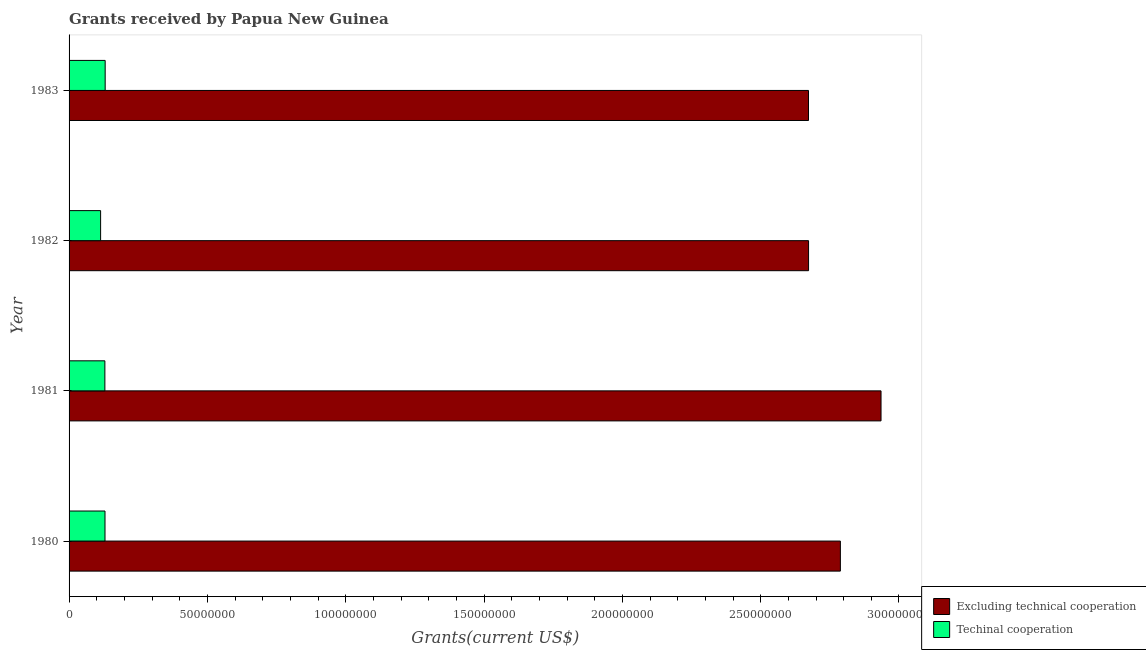How many different coloured bars are there?
Make the answer very short. 2. How many groups of bars are there?
Your response must be concise. 4. Are the number of bars per tick equal to the number of legend labels?
Make the answer very short. Yes. Are the number of bars on each tick of the Y-axis equal?
Your response must be concise. Yes. In how many cases, is the number of bars for a given year not equal to the number of legend labels?
Your answer should be very brief. 0. What is the amount of grants received(excluding technical cooperation) in 1981?
Your answer should be compact. 2.94e+08. Across all years, what is the maximum amount of grants received(including technical cooperation)?
Your response must be concise. 1.30e+07. Across all years, what is the minimum amount of grants received(including technical cooperation)?
Offer a terse response. 1.14e+07. In which year was the amount of grants received(including technical cooperation) minimum?
Your response must be concise. 1982. What is the total amount of grants received(excluding technical cooperation) in the graph?
Provide a short and direct response. 1.11e+09. What is the difference between the amount of grants received(excluding technical cooperation) in 1980 and that in 1981?
Offer a terse response. -1.47e+07. What is the difference between the amount of grants received(excluding technical cooperation) in 1980 and the amount of grants received(including technical cooperation) in 1983?
Offer a terse response. 2.66e+08. What is the average amount of grants received(including technical cooperation) per year?
Provide a succinct answer. 1.26e+07. In the year 1980, what is the difference between the amount of grants received(including technical cooperation) and amount of grants received(excluding technical cooperation)?
Provide a short and direct response. -2.66e+08. In how many years, is the amount of grants received(excluding technical cooperation) greater than 160000000 US$?
Offer a terse response. 4. What is the ratio of the amount of grants received(including technical cooperation) in 1982 to that in 1983?
Provide a succinct answer. 0.87. Is the difference between the amount of grants received(including technical cooperation) in 1980 and 1981 greater than the difference between the amount of grants received(excluding technical cooperation) in 1980 and 1981?
Offer a terse response. Yes. What is the difference between the highest and the second highest amount of grants received(excluding technical cooperation)?
Your answer should be compact. 1.47e+07. What is the difference between the highest and the lowest amount of grants received(including technical cooperation)?
Make the answer very short. 1.65e+06. In how many years, is the amount of grants received(including technical cooperation) greater than the average amount of grants received(including technical cooperation) taken over all years?
Your answer should be very brief. 3. What does the 2nd bar from the top in 1980 represents?
Provide a short and direct response. Excluding technical cooperation. What does the 2nd bar from the bottom in 1982 represents?
Make the answer very short. Techinal cooperation. How many bars are there?
Your answer should be compact. 8. Are all the bars in the graph horizontal?
Your response must be concise. Yes. Where does the legend appear in the graph?
Offer a terse response. Bottom right. How many legend labels are there?
Provide a short and direct response. 2. What is the title of the graph?
Keep it short and to the point. Grants received by Papua New Guinea. Does "current US$" appear as one of the legend labels in the graph?
Offer a very short reply. No. What is the label or title of the X-axis?
Provide a succinct answer. Grants(current US$). What is the Grants(current US$) in Excluding technical cooperation in 1980?
Your answer should be very brief. 2.79e+08. What is the Grants(current US$) in Techinal cooperation in 1980?
Offer a terse response. 1.30e+07. What is the Grants(current US$) of Excluding technical cooperation in 1981?
Your answer should be very brief. 2.94e+08. What is the Grants(current US$) of Techinal cooperation in 1981?
Your answer should be compact. 1.29e+07. What is the Grants(current US$) in Excluding technical cooperation in 1982?
Make the answer very short. 2.67e+08. What is the Grants(current US$) in Techinal cooperation in 1982?
Offer a terse response. 1.14e+07. What is the Grants(current US$) of Excluding technical cooperation in 1983?
Your response must be concise. 2.67e+08. What is the Grants(current US$) of Techinal cooperation in 1983?
Offer a terse response. 1.30e+07. Across all years, what is the maximum Grants(current US$) of Excluding technical cooperation?
Your answer should be compact. 2.94e+08. Across all years, what is the maximum Grants(current US$) in Techinal cooperation?
Keep it short and to the point. 1.30e+07. Across all years, what is the minimum Grants(current US$) in Excluding technical cooperation?
Your answer should be very brief. 2.67e+08. Across all years, what is the minimum Grants(current US$) of Techinal cooperation?
Offer a terse response. 1.14e+07. What is the total Grants(current US$) in Excluding technical cooperation in the graph?
Give a very brief answer. 1.11e+09. What is the total Grants(current US$) in Techinal cooperation in the graph?
Ensure brevity in your answer.  5.04e+07. What is the difference between the Grants(current US$) in Excluding technical cooperation in 1980 and that in 1981?
Make the answer very short. -1.47e+07. What is the difference between the Grants(current US$) in Excluding technical cooperation in 1980 and that in 1982?
Provide a short and direct response. 1.15e+07. What is the difference between the Grants(current US$) of Techinal cooperation in 1980 and that in 1982?
Your answer should be compact. 1.59e+06. What is the difference between the Grants(current US$) of Excluding technical cooperation in 1980 and that in 1983?
Offer a terse response. 1.15e+07. What is the difference between the Grants(current US$) in Excluding technical cooperation in 1981 and that in 1982?
Provide a succinct answer. 2.62e+07. What is the difference between the Grants(current US$) in Techinal cooperation in 1981 and that in 1982?
Make the answer very short. 1.54e+06. What is the difference between the Grants(current US$) of Excluding technical cooperation in 1981 and that in 1983?
Your response must be concise. 2.62e+07. What is the difference between the Grants(current US$) of Techinal cooperation in 1982 and that in 1983?
Give a very brief answer. -1.65e+06. What is the difference between the Grants(current US$) in Excluding technical cooperation in 1980 and the Grants(current US$) in Techinal cooperation in 1981?
Provide a short and direct response. 2.66e+08. What is the difference between the Grants(current US$) in Excluding technical cooperation in 1980 and the Grants(current US$) in Techinal cooperation in 1982?
Provide a succinct answer. 2.67e+08. What is the difference between the Grants(current US$) of Excluding technical cooperation in 1980 and the Grants(current US$) of Techinal cooperation in 1983?
Your answer should be very brief. 2.66e+08. What is the difference between the Grants(current US$) in Excluding technical cooperation in 1981 and the Grants(current US$) in Techinal cooperation in 1982?
Your answer should be very brief. 2.82e+08. What is the difference between the Grants(current US$) of Excluding technical cooperation in 1981 and the Grants(current US$) of Techinal cooperation in 1983?
Your answer should be very brief. 2.80e+08. What is the difference between the Grants(current US$) of Excluding technical cooperation in 1982 and the Grants(current US$) of Techinal cooperation in 1983?
Ensure brevity in your answer.  2.54e+08. What is the average Grants(current US$) of Excluding technical cooperation per year?
Your response must be concise. 2.77e+08. What is the average Grants(current US$) in Techinal cooperation per year?
Offer a very short reply. 1.26e+07. In the year 1980, what is the difference between the Grants(current US$) in Excluding technical cooperation and Grants(current US$) in Techinal cooperation?
Offer a terse response. 2.66e+08. In the year 1981, what is the difference between the Grants(current US$) in Excluding technical cooperation and Grants(current US$) in Techinal cooperation?
Provide a short and direct response. 2.81e+08. In the year 1982, what is the difference between the Grants(current US$) of Excluding technical cooperation and Grants(current US$) of Techinal cooperation?
Offer a terse response. 2.56e+08. In the year 1983, what is the difference between the Grants(current US$) in Excluding technical cooperation and Grants(current US$) in Techinal cooperation?
Make the answer very short. 2.54e+08. What is the ratio of the Grants(current US$) of Excluding technical cooperation in 1980 to that in 1981?
Give a very brief answer. 0.95. What is the ratio of the Grants(current US$) in Excluding technical cooperation in 1980 to that in 1982?
Your answer should be very brief. 1.04. What is the ratio of the Grants(current US$) in Techinal cooperation in 1980 to that in 1982?
Offer a terse response. 1.14. What is the ratio of the Grants(current US$) in Excluding technical cooperation in 1980 to that in 1983?
Ensure brevity in your answer.  1.04. What is the ratio of the Grants(current US$) of Techinal cooperation in 1980 to that in 1983?
Keep it short and to the point. 1. What is the ratio of the Grants(current US$) in Excluding technical cooperation in 1981 to that in 1982?
Your answer should be very brief. 1.1. What is the ratio of the Grants(current US$) in Techinal cooperation in 1981 to that in 1982?
Ensure brevity in your answer.  1.14. What is the ratio of the Grants(current US$) in Excluding technical cooperation in 1981 to that in 1983?
Make the answer very short. 1.1. What is the ratio of the Grants(current US$) in Techinal cooperation in 1981 to that in 1983?
Provide a short and direct response. 0.99. What is the ratio of the Grants(current US$) in Excluding technical cooperation in 1982 to that in 1983?
Make the answer very short. 1. What is the ratio of the Grants(current US$) of Techinal cooperation in 1982 to that in 1983?
Provide a succinct answer. 0.87. What is the difference between the highest and the second highest Grants(current US$) in Excluding technical cooperation?
Offer a terse response. 1.47e+07. What is the difference between the highest and the second highest Grants(current US$) in Techinal cooperation?
Your response must be concise. 6.00e+04. What is the difference between the highest and the lowest Grants(current US$) in Excluding technical cooperation?
Your answer should be compact. 2.62e+07. What is the difference between the highest and the lowest Grants(current US$) of Techinal cooperation?
Your answer should be very brief. 1.65e+06. 